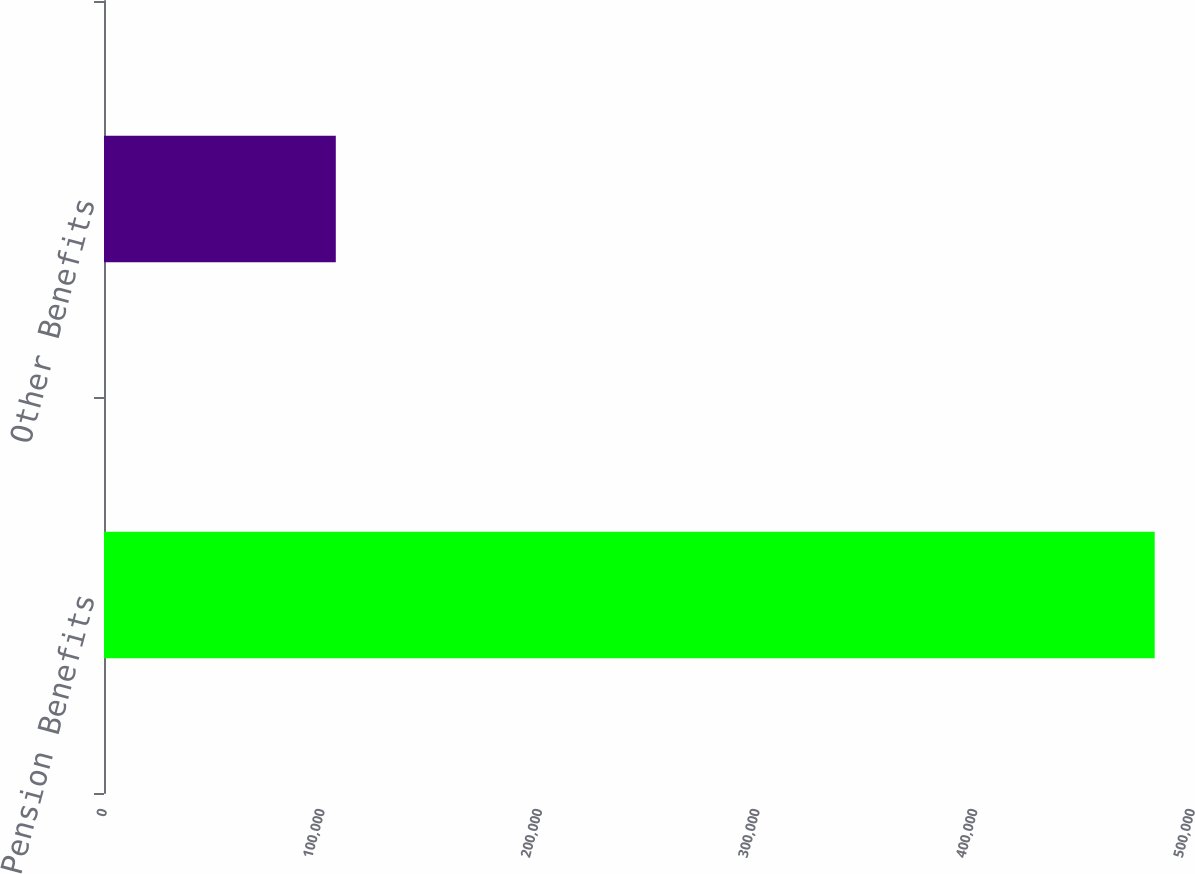Convert chart. <chart><loc_0><loc_0><loc_500><loc_500><bar_chart><fcel>Pension Benefits<fcel>Other Benefits<nl><fcel>482861<fcel>106526<nl></chart> 